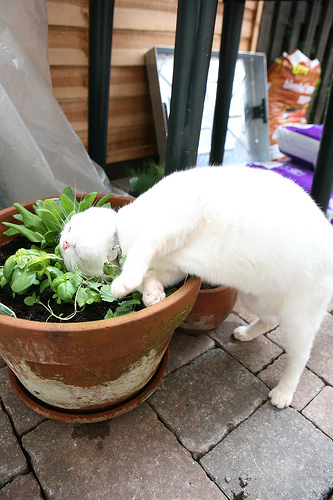What unique feature of the pot can you identify? One unique feature of the pot is its rustic appearance with a weathered surface, displaying a pattern of aging that adds character to the setting. The pot has a mix of brown and green hues from moss growth, contributing to the natural and earthy feel of the scene. 